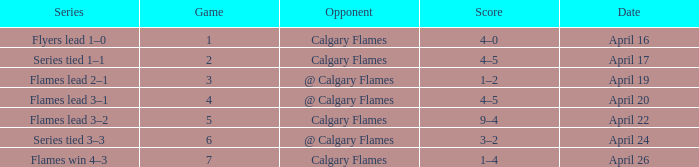Which Series has a Score of 9–4? Flames lead 3–2. 